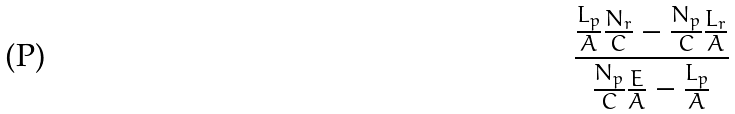Convert formula to latex. <formula><loc_0><loc_0><loc_500><loc_500>\frac { \frac { L _ { p } } { A } \frac { N _ { r } } { C } - \frac { N _ { p } } { C } \frac { L _ { r } } { A } } { \frac { N _ { p } } { C } \frac { E } { A } - \frac { L _ { p } } { A } }</formula> 